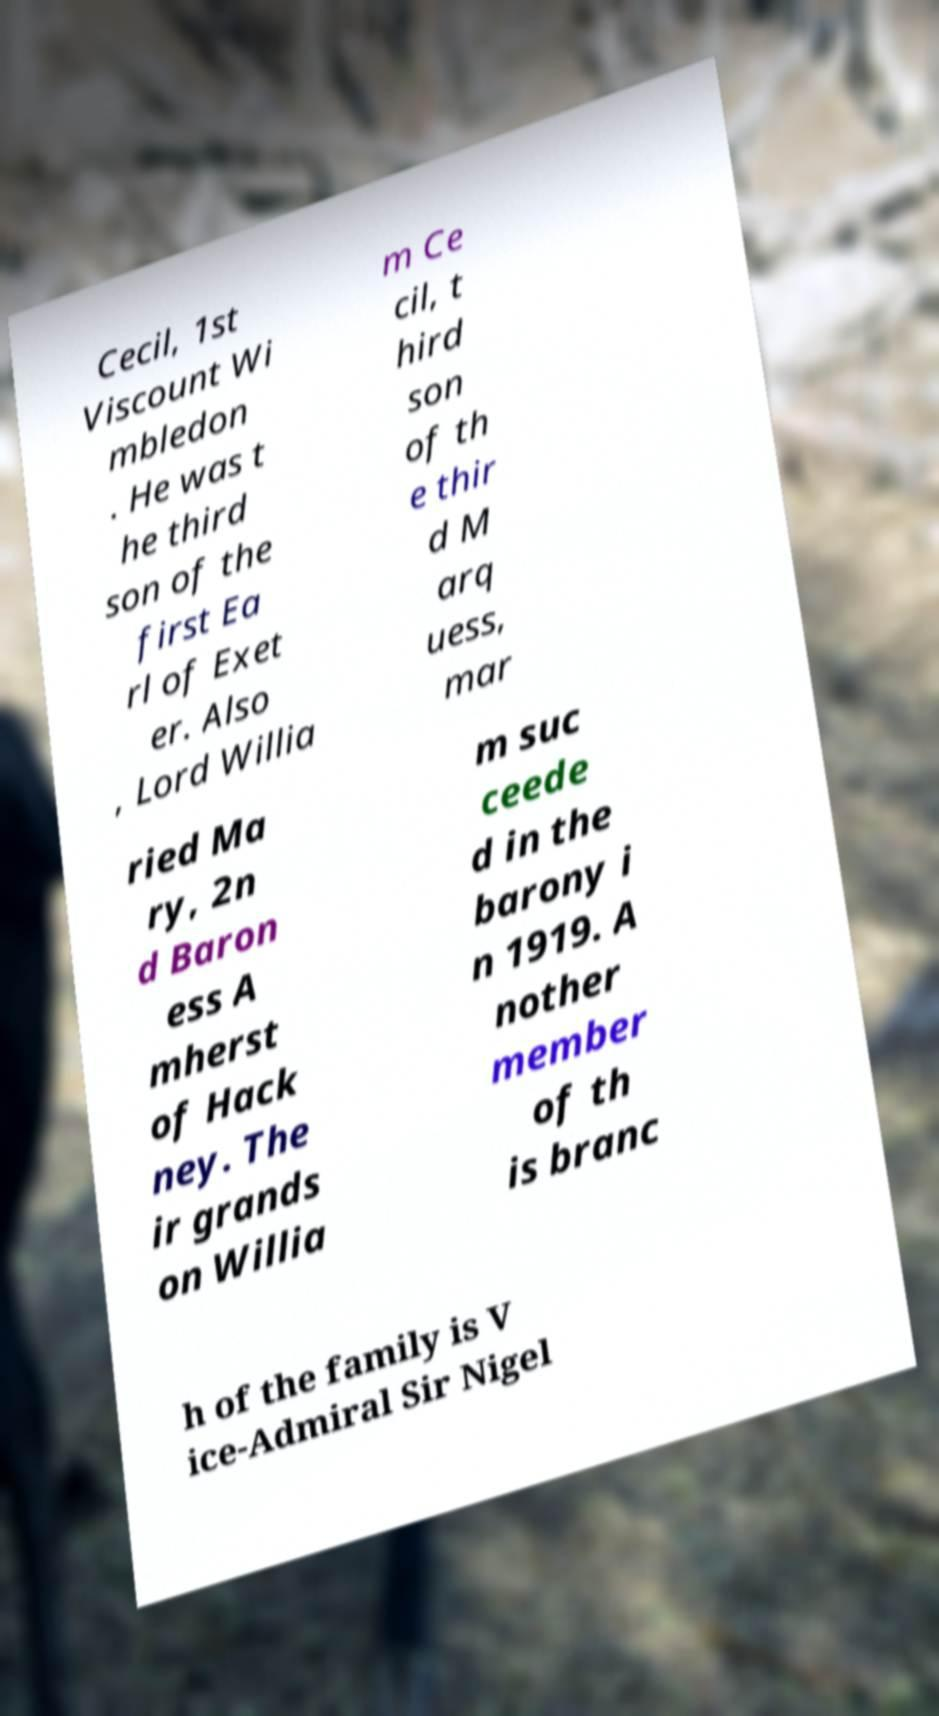Could you assist in decoding the text presented in this image and type it out clearly? Cecil, 1st Viscount Wi mbledon . He was t he third son of the first Ea rl of Exet er. Also , Lord Willia m Ce cil, t hird son of th e thir d M arq uess, mar ried Ma ry, 2n d Baron ess A mherst of Hack ney. The ir grands on Willia m suc ceede d in the barony i n 1919. A nother member of th is branc h of the family is V ice-Admiral Sir Nigel 